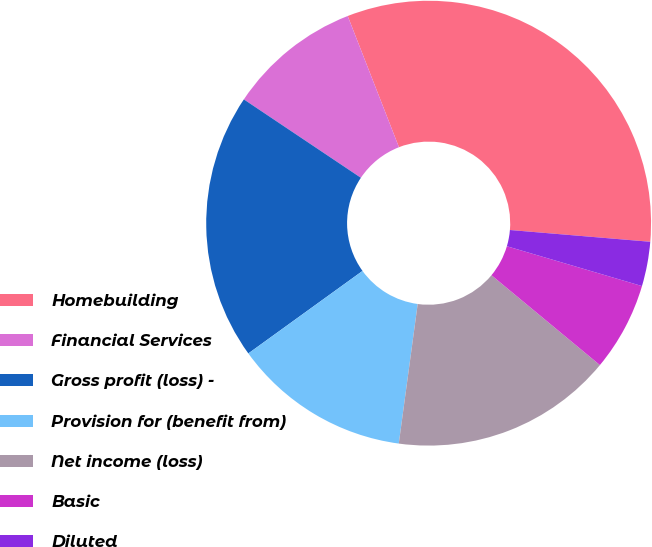<chart> <loc_0><loc_0><loc_500><loc_500><pie_chart><fcel>Homebuilding<fcel>Financial Services<fcel>Gross profit (loss) -<fcel>Provision for (benefit from)<fcel>Net income (loss)<fcel>Basic<fcel>Diluted<fcel>Cash dividends declared per<nl><fcel>32.26%<fcel>9.68%<fcel>19.35%<fcel>12.9%<fcel>16.13%<fcel>6.45%<fcel>3.23%<fcel>0.0%<nl></chart> 